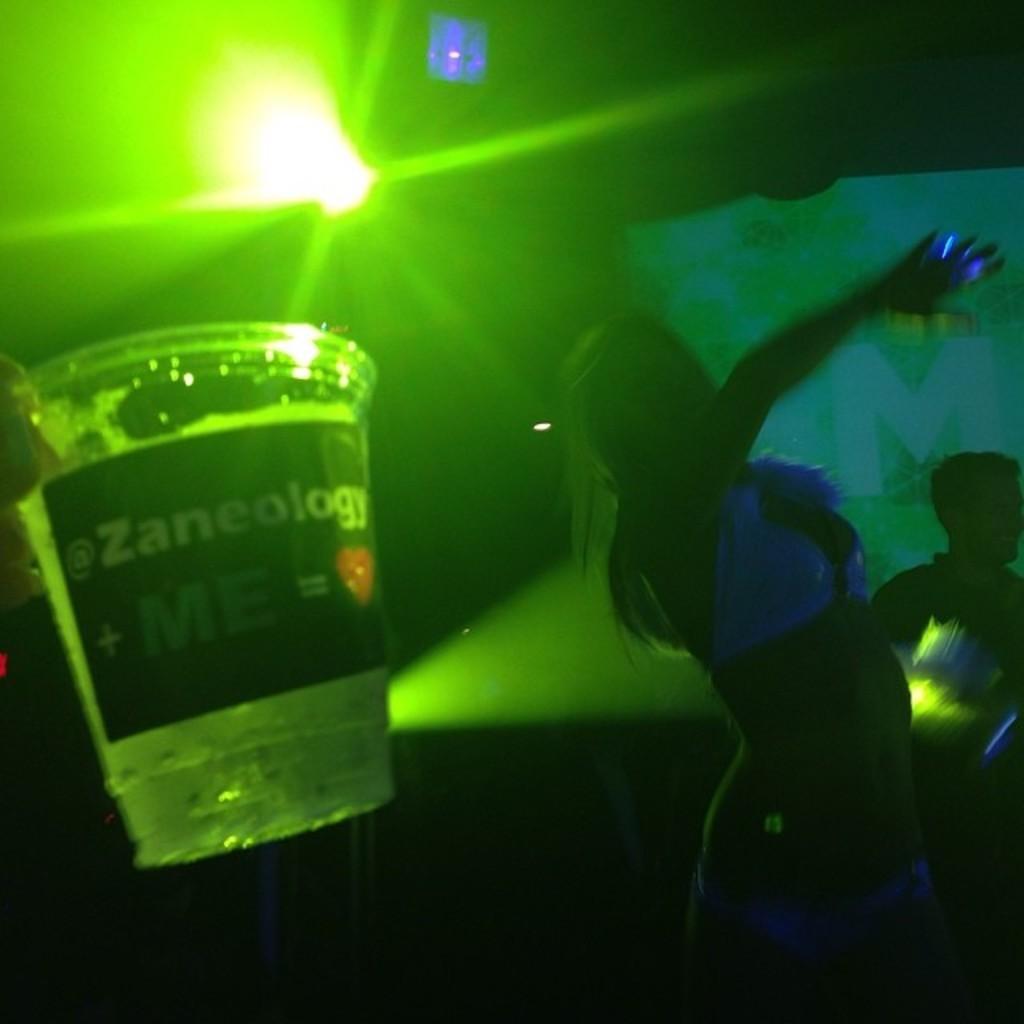Can you describe this image briefly? This is the woman dancing. I can see a glass with a label on it. This is the light, which is green in color. In the background, that looks like a person standing. 